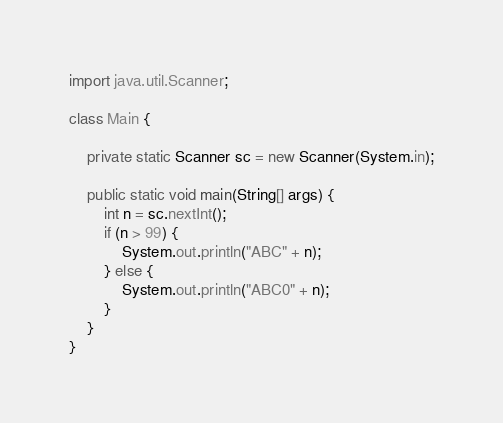Convert code to text. <code><loc_0><loc_0><loc_500><loc_500><_Java_>import java.util.Scanner;

class Main {

    private static Scanner sc = new Scanner(System.in);

    public static void main(String[] args) {
        int n = sc.nextInt();
        if (n > 99) {
            System.out.println("ABC" + n);
        } else {
            System.out.println("ABC0" + n);
        }
    }
}</code> 